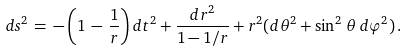Convert formula to latex. <formula><loc_0><loc_0><loc_500><loc_500>d s ^ { 2 } \, = \, - \left ( 1 \, - \, \frac { 1 } { r } \right ) d t ^ { 2 } + \frac { d r ^ { 2 } } { 1 - 1 / r } + r ^ { 2 } ( d \theta ^ { 2 } + \sin ^ { 2 } \, \theta \, d \varphi ^ { 2 } ) \, .</formula> 